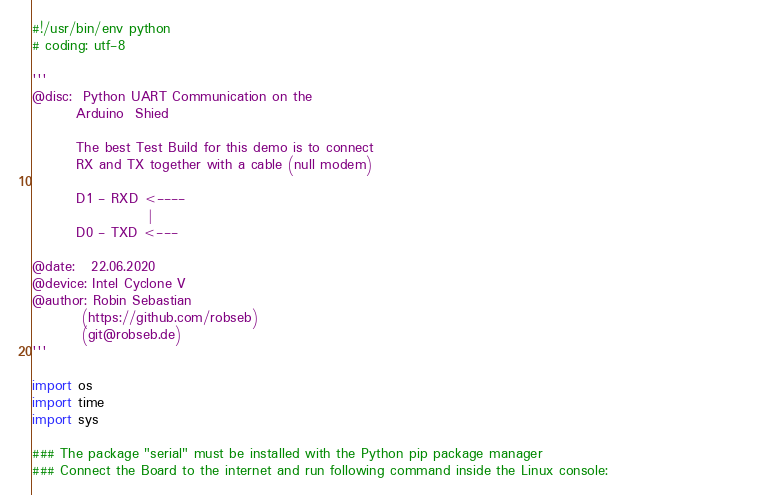Convert code to text. <code><loc_0><loc_0><loc_500><loc_500><_Python_>#!/usr/bin/env python
# coding: utf-8

'''
@disc:  Python UART Communication on the 
        Arduino  Shied
        
        The best Test Build for this demo is to connect 
        RX and TX together with a cable (null modem)

        D1 - RXD <----
                     |
        D0 - TXD <---
         
@date:   22.06.2020
@device: Intel Cyclone V 
@author: Robin Sebastian
         (https://github.com/robseb)
         (git@robseb.de)
'''

import os
import time
import sys

### The package "serial" must be installed with the Python pip package manager                                        
### Connect the Board to the internet and run following command inside the Linux console:          </code> 